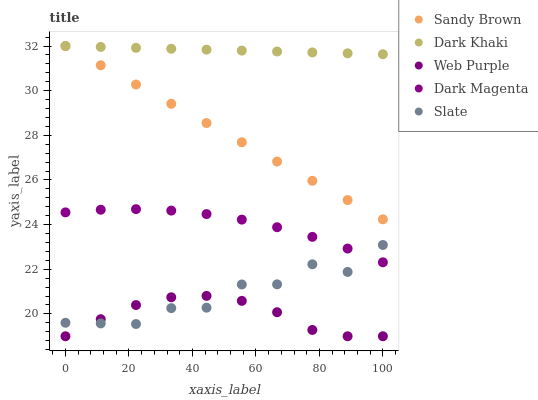Does Web Purple have the minimum area under the curve?
Answer yes or no. Yes. Does Dark Khaki have the maximum area under the curve?
Answer yes or no. Yes. Does Slate have the minimum area under the curve?
Answer yes or no. No. Does Slate have the maximum area under the curve?
Answer yes or no. No. Is Sandy Brown the smoothest?
Answer yes or no. Yes. Is Slate the roughest?
Answer yes or no. Yes. Is Web Purple the smoothest?
Answer yes or no. No. Is Web Purple the roughest?
Answer yes or no. No. Does Web Purple have the lowest value?
Answer yes or no. Yes. Does Slate have the lowest value?
Answer yes or no. No. Does Sandy Brown have the highest value?
Answer yes or no. Yes. Does Slate have the highest value?
Answer yes or no. No. Is Web Purple less than Sandy Brown?
Answer yes or no. Yes. Is Dark Khaki greater than Web Purple?
Answer yes or no. Yes. Does Slate intersect Web Purple?
Answer yes or no. Yes. Is Slate less than Web Purple?
Answer yes or no. No. Is Slate greater than Web Purple?
Answer yes or no. No. Does Web Purple intersect Sandy Brown?
Answer yes or no. No. 